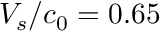Convert formula to latex. <formula><loc_0><loc_0><loc_500><loc_500>V _ { s } / c _ { 0 } = 0 . 6 5</formula> 